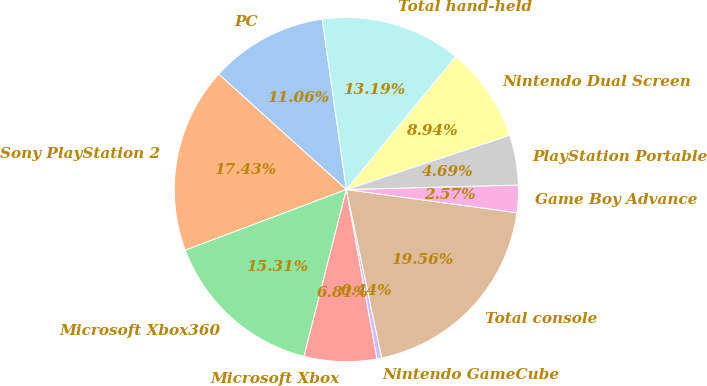Convert chart to OTSL. <chart><loc_0><loc_0><loc_500><loc_500><pie_chart><fcel>PC<fcel>Sony PlayStation 2<fcel>Microsoft Xbox360<fcel>Microsoft Xbox<fcel>Nintendo GameCube<fcel>Total console<fcel>Game Boy Advance<fcel>PlayStation Portable<fcel>Nintendo Dual Screen<fcel>Total hand-held<nl><fcel>11.06%<fcel>17.43%<fcel>15.31%<fcel>6.81%<fcel>0.44%<fcel>19.56%<fcel>2.57%<fcel>4.69%<fcel>8.94%<fcel>13.19%<nl></chart> 